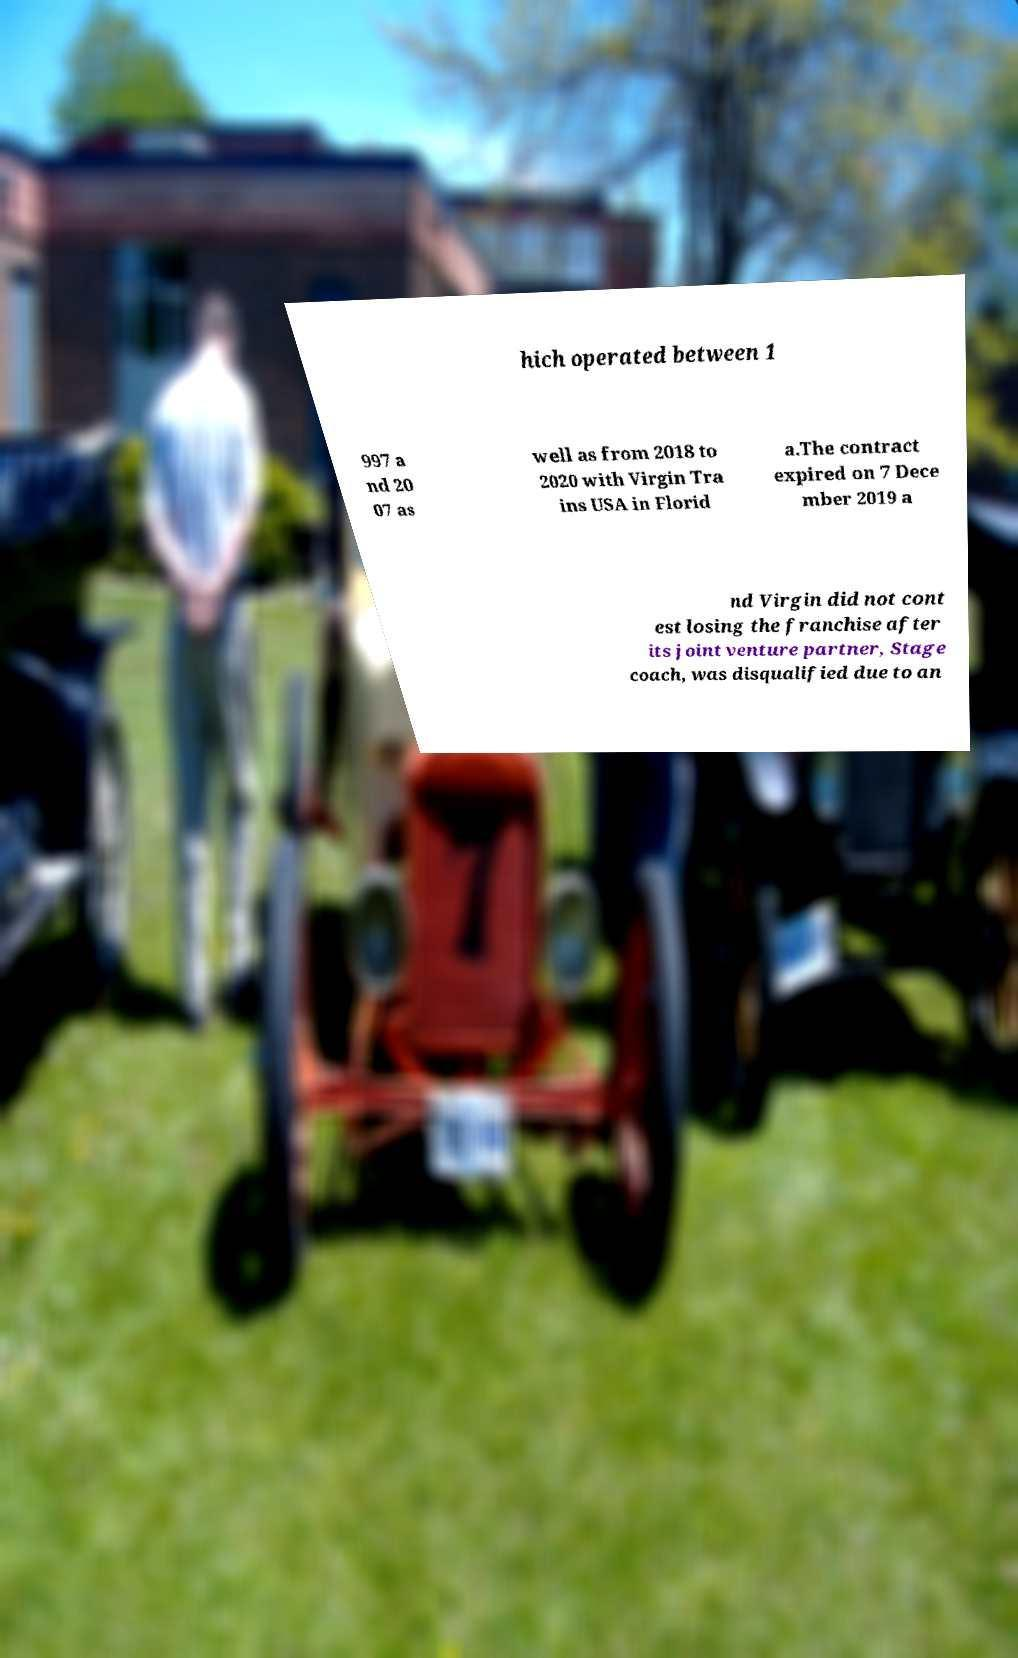I need the written content from this picture converted into text. Can you do that? hich operated between 1 997 a nd 20 07 as well as from 2018 to 2020 with Virgin Tra ins USA in Florid a.The contract expired on 7 Dece mber 2019 a nd Virgin did not cont est losing the franchise after its joint venture partner, Stage coach, was disqualified due to an 